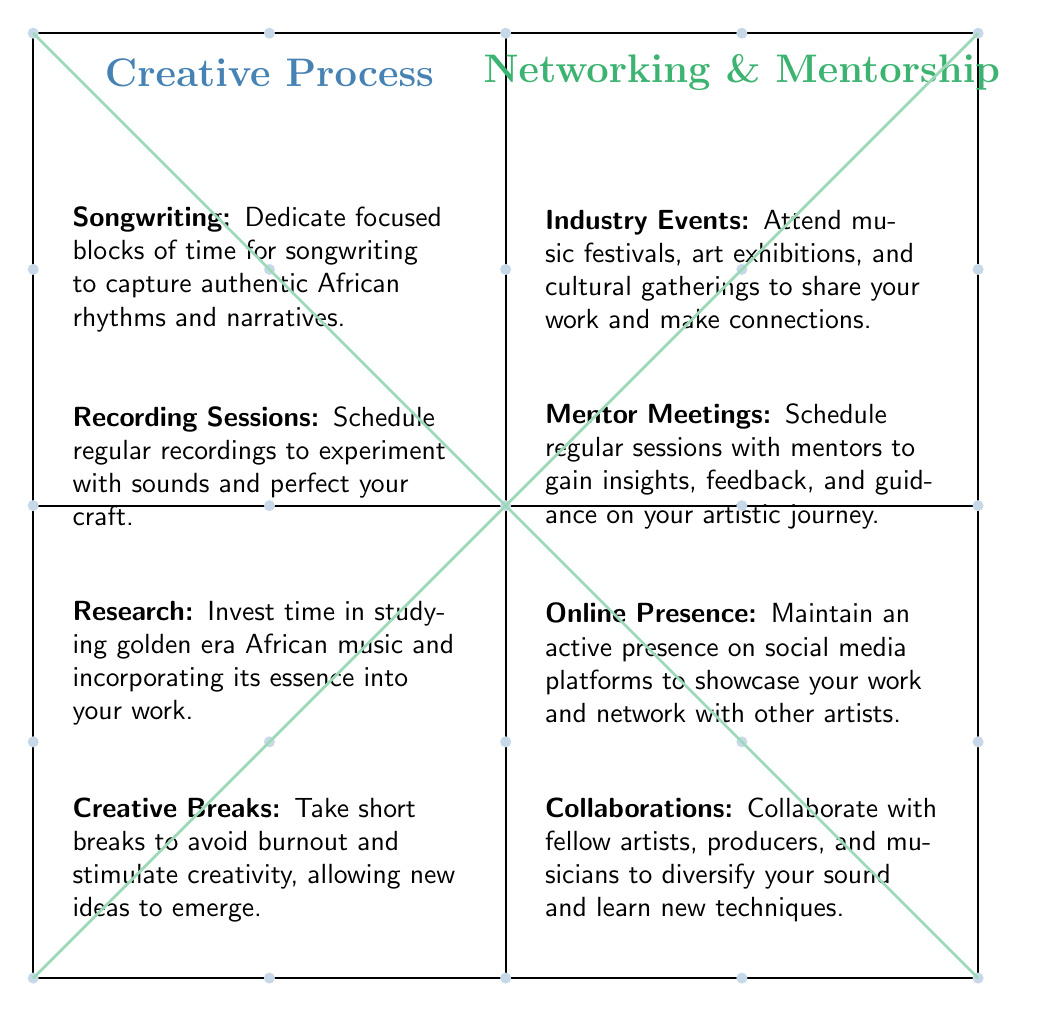What is listed under the Creative Process quadrant? Under the Creative Process quadrant, there are four elements: Songwriting, Recording Sessions, Research, and Creative Breaks. These terms summarize key activities relevant to the creative work of the artist.
Answer: Songwriting, Recording Sessions, Research, Creative Breaks How many elements are in the Networking & Mentorship quadrant? The Networking & Mentorship quadrant contains four elements as well: Industry Events, Mentor Meetings, Online Presence, and Collaborations. Counting these elements leads us to the total.
Answer: 4 What is the main focus of the Research item in the Creative Process? The main focus of Research in the Creative Process is about understanding golden era African music and integrating its essence into new works. This indicates a deep connection to cultural roots.
Answer: Studying golden era African music Which element emphasizes maintaining an online presence? The element that emphasizes maintaining an online presence is Online Presence under the Networking & Mentorship quadrant. This highlights the importance of digital engagement for the artist.
Answer: Online Presence How do Creative Breaks contribute to the creative process? Creative Breaks contribute to the creative process by preventing burnout and allowing new ideas to emerge, indicating their role in enhancing creativity and productivity.
Answer: Stimulate creativity Which element might facilitate collaboration with fellow artists? Collaborations listed under Networking & Mentorship would facilitate working with fellow artists, as this element directly states the intention of collaborative efforts.
Answer: Collaborations In which quadrant would you find Recording Sessions? Recording Sessions are found in the Creative Process quadrant, where these sessions are crucial for experimenting and perfecting musical craft.
Answer: Creative Process What is a key activity suggested for Networking & Mentorship? A key activity suggested for Networking & Mentorship is attending Industry Events, which serves to share the artist's work and create connections within the industry.
Answer: Industry Events Which aspect of the Creative Process helps capture authentic narratives? Songwriting is the aspect of the Creative Process that helps capture authentic African rhythms and narratives through dedicated focused time.
Answer: Songwriting 